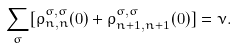<formula> <loc_0><loc_0><loc_500><loc_500>\sum _ { \sigma } [ \rho ^ { \sigma , \sigma } _ { n , n } ( 0 ) + \rho ^ { \sigma , \sigma } _ { n + 1 , n + 1 } ( 0 ) ] = \nu .</formula> 